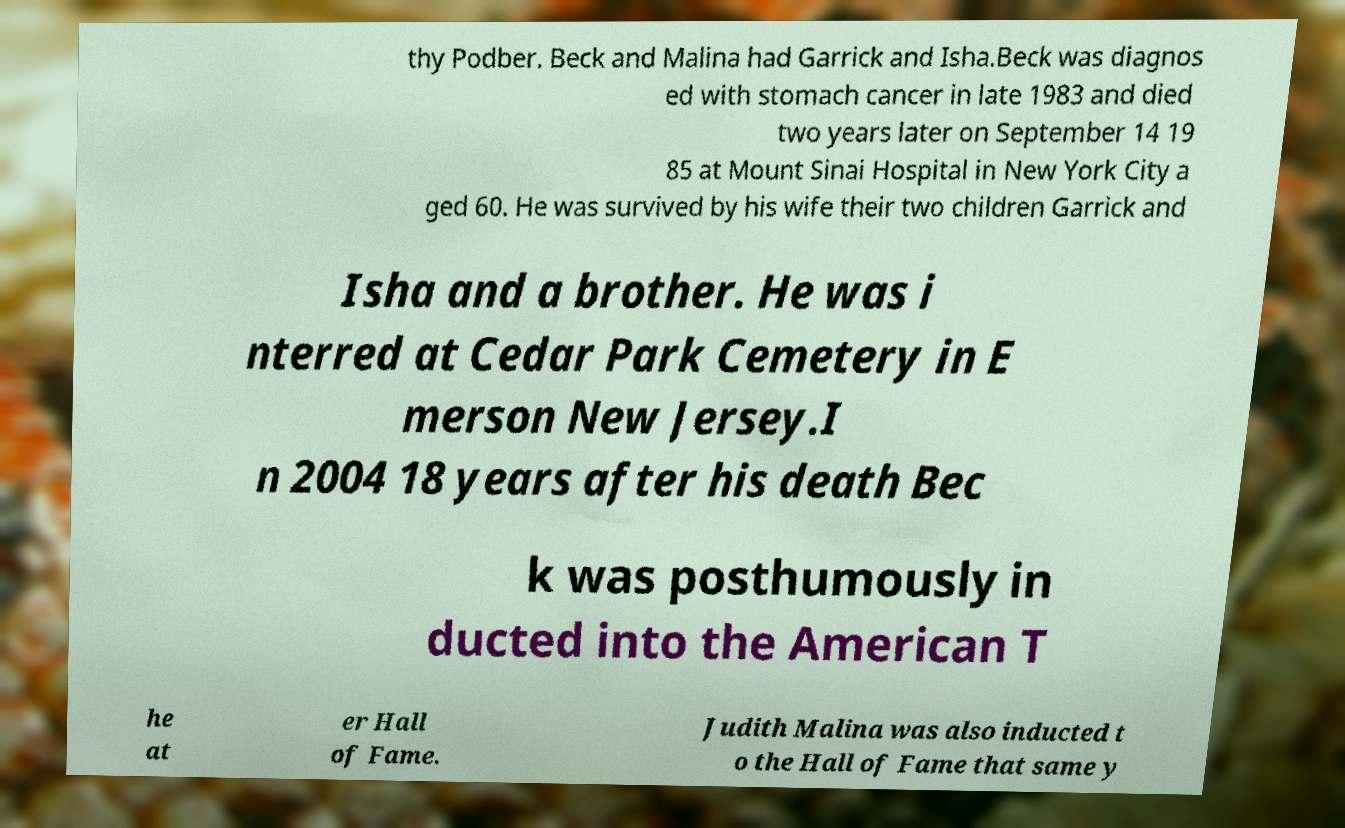For documentation purposes, I need the text within this image transcribed. Could you provide that? Certainly! The text in the image appears to be partially cut off and hard to read in places, but here is a clearer transcription: 'Beck and Malina had Garrick and Isha. Beck was diagnosed with stomach cancer in late 1983 and died two years later on September 14, 1985 at Mount Sinai Hospital in New York City, aged 60. He was survived by his wife, their two children Garrick and Isha, and a brother. He was interred at Cedar Park Cemetery in Emerson, New Jersey. In 2004, 18 years after his death, Beck was posthumously inducted into the American Theater Hall of Fame. Judith Malina was also inducted into the Hall of Fame that same year.' 